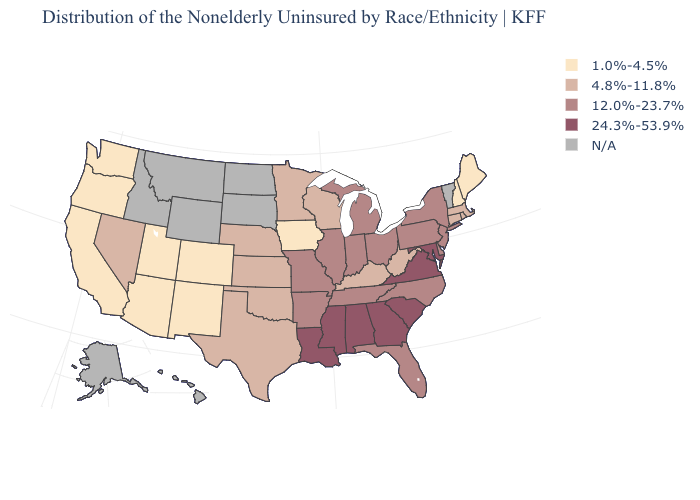Does the first symbol in the legend represent the smallest category?
Short answer required. Yes. What is the value of Vermont?
Concise answer only. N/A. Name the states that have a value in the range 4.8%-11.8%?
Give a very brief answer. Connecticut, Kansas, Kentucky, Massachusetts, Minnesota, Nebraska, Nevada, Oklahoma, Rhode Island, Texas, West Virginia, Wisconsin. Among the states that border Maryland , does Virginia have the highest value?
Write a very short answer. Yes. Does the map have missing data?
Give a very brief answer. Yes. Does Maryland have the highest value in the USA?
Be succinct. Yes. Does the first symbol in the legend represent the smallest category?
Quick response, please. Yes. Name the states that have a value in the range 24.3%-53.9%?
Keep it brief. Alabama, Georgia, Louisiana, Maryland, Mississippi, South Carolina, Virginia. What is the highest value in the West ?
Keep it brief. 4.8%-11.8%. What is the value of Utah?
Keep it brief. 1.0%-4.5%. What is the value of Utah?
Answer briefly. 1.0%-4.5%. What is the highest value in the USA?
Short answer required. 24.3%-53.9%. Does Iowa have the lowest value in the MidWest?
Be succinct. Yes. How many symbols are there in the legend?
Give a very brief answer. 5. 